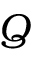<formula> <loc_0><loc_0><loc_500><loc_500>Q</formula> 